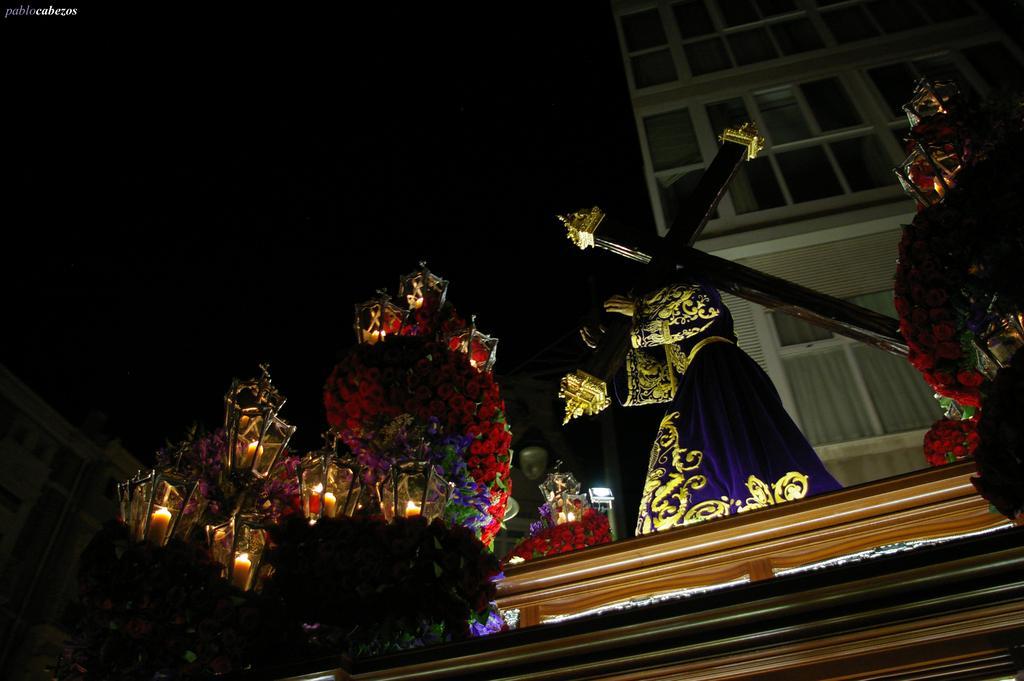Can you describe this image briefly? In this picture I can see there is a person holding the cross and there are few flowers and lights. There are few lights attached here and there is a building in the backdrop and it has windows and there is another building here and the sky is dark. 